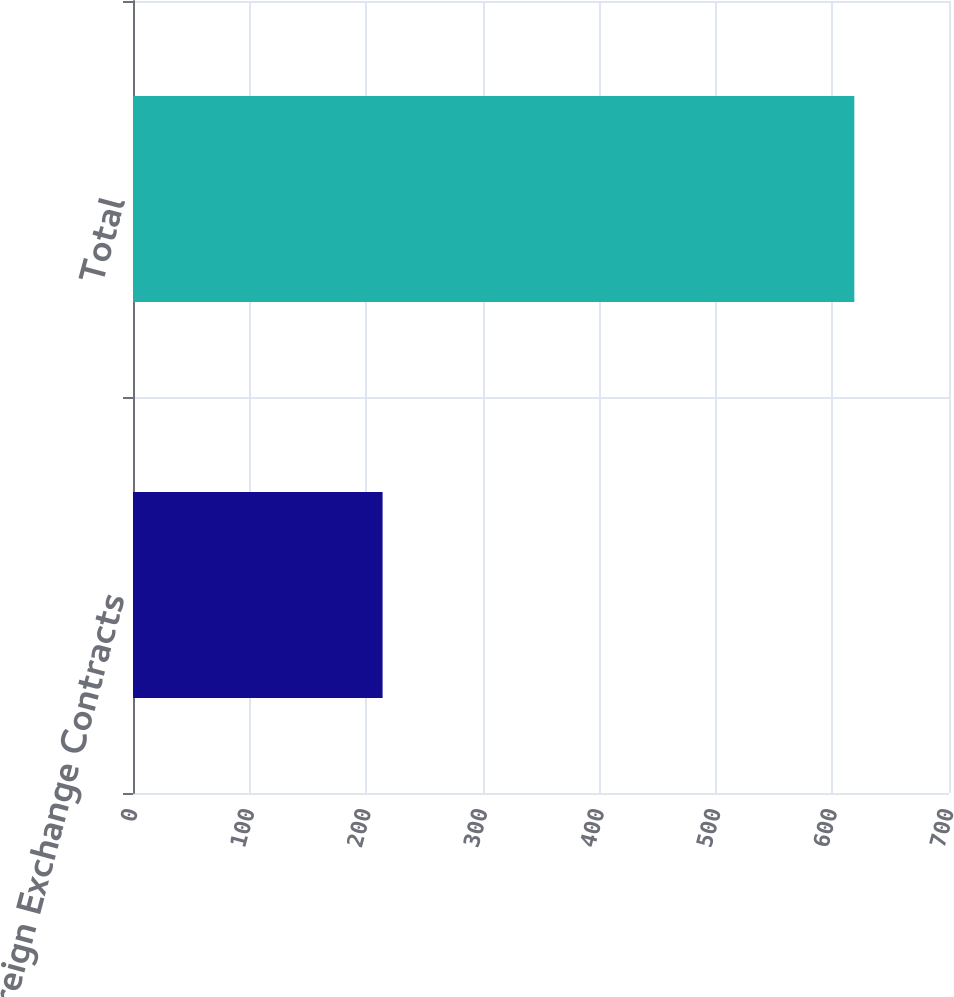Convert chart. <chart><loc_0><loc_0><loc_500><loc_500><bar_chart><fcel>Foreign Exchange Contracts<fcel>Total<nl><fcel>214.1<fcel>618.8<nl></chart> 